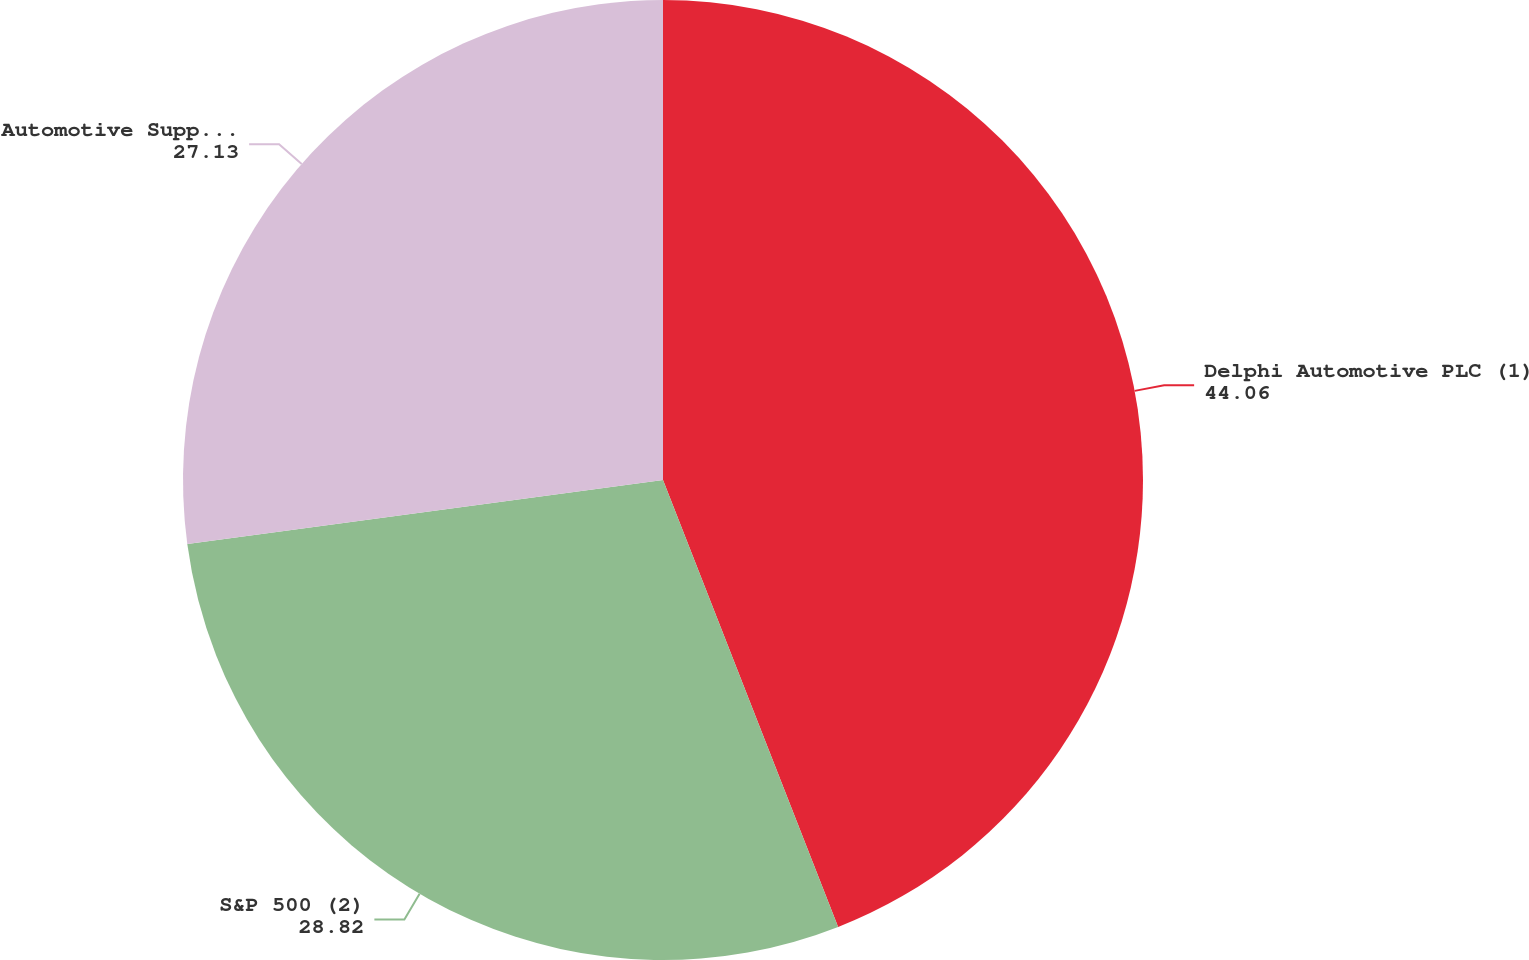Convert chart to OTSL. <chart><loc_0><loc_0><loc_500><loc_500><pie_chart><fcel>Delphi Automotive PLC (1)<fcel>S&P 500 (2)<fcel>Automotive Supplier Peer Group<nl><fcel>44.06%<fcel>28.82%<fcel>27.13%<nl></chart> 